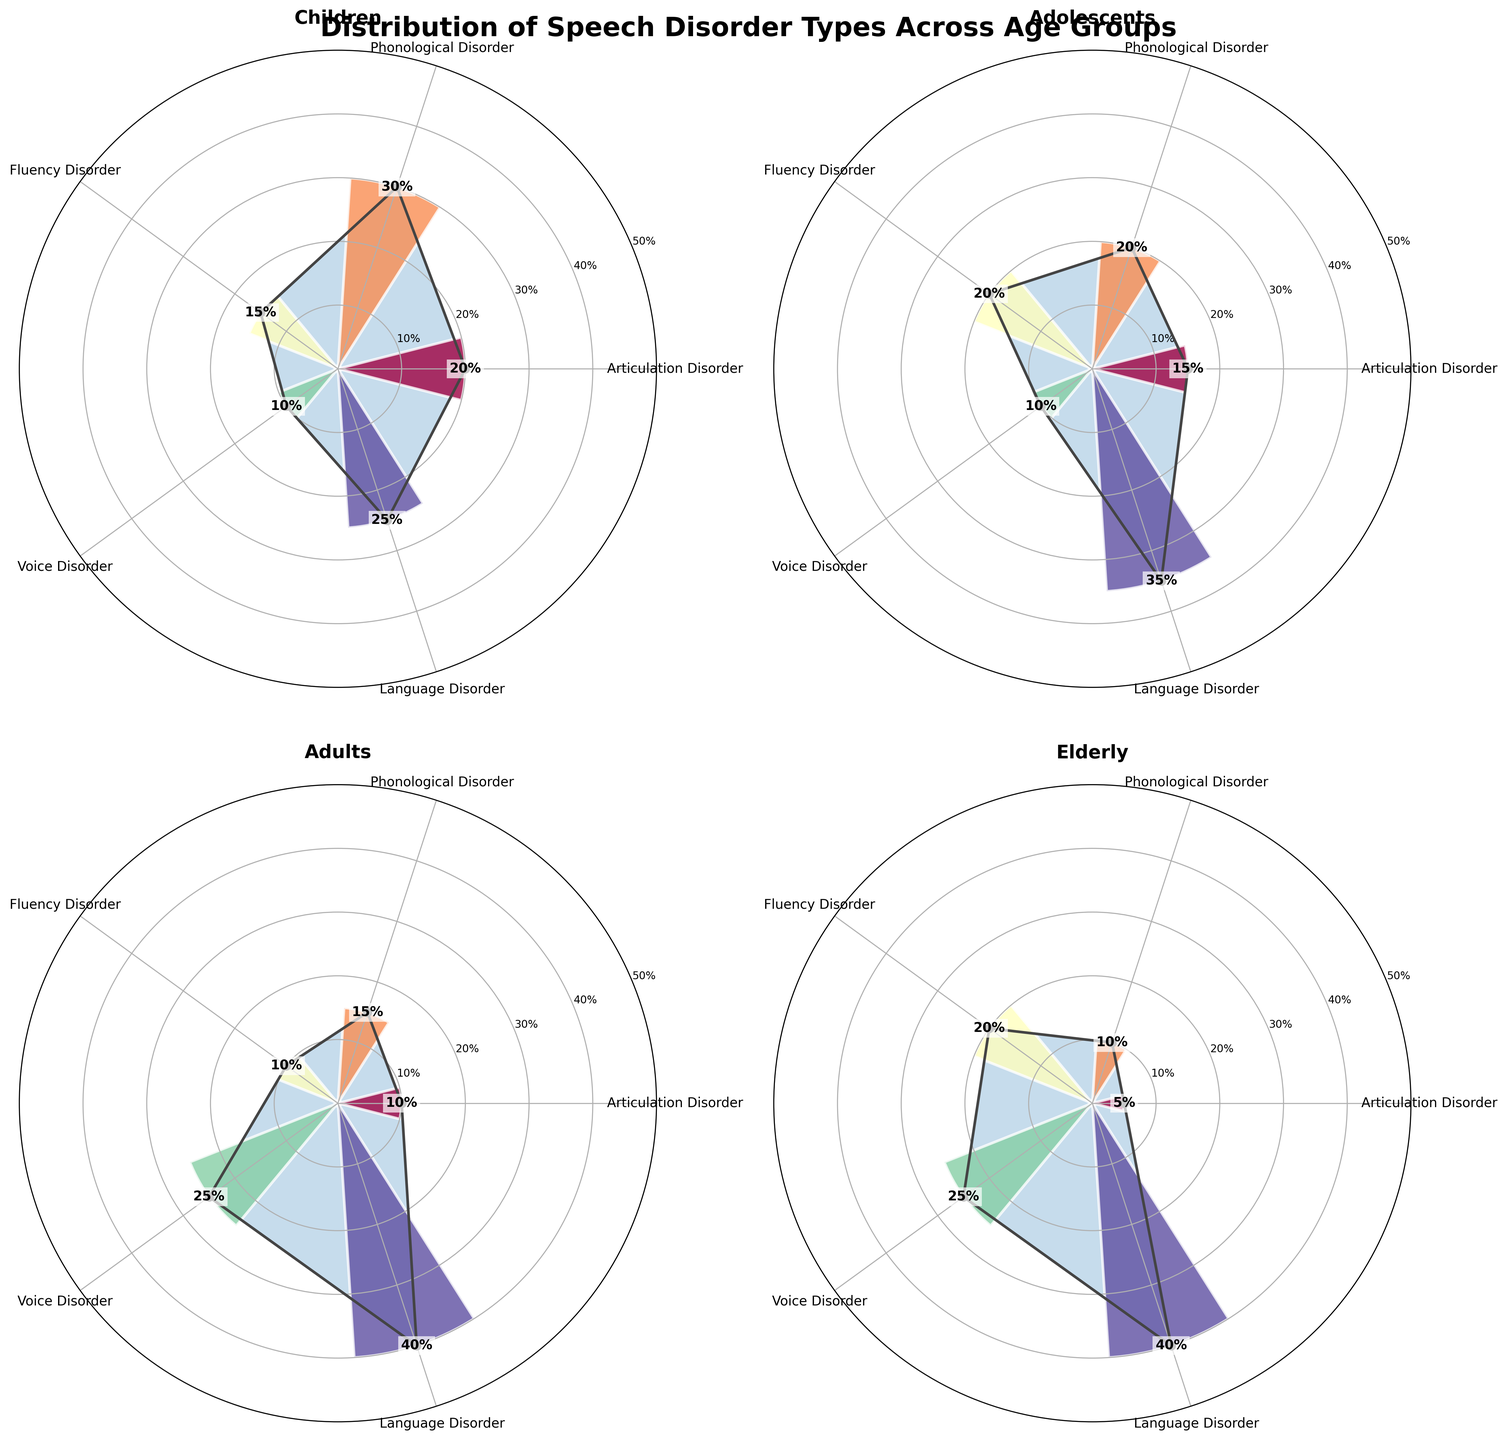What are the different types of speech disorders presented in the figure? The figure showcases five different speech disorder types as radial sections in each subplot. They are Articulation Disorder, Phonological Disorder, Fluency Disorder, Voice Disorder, and Language Disorder.
Answer: Articulation Disorder, Phonological Disorder, Fluency Disorder, Voice Disorder, Language Disorder Which age group has the highest percentage of Language Disorders? By visually inspecting the percentage values of Language Disorders in each subplot, you find the highest value within the "Elderly" group at 40%.
Answer: Elderly In the "Children" age group, which speech disorder has the lowest prevalence? Examining the "Children" subplot, the disorder with the smallest percentage is "Voice Disorder" with 10%.
Answer: Voice Disorder Compare the prevalence of Fluency Disorders between "Adolescents" and "Adults". Which age group has a higher percentage? The Fluency Disorder percentage for "Adolescents" is 20%, whereas for "Adults" it is 10%. Thus, "Adolescents" have a higher percentage.
Answer: Adolescents What is the combined percentage of Articulation Disorders across all age groups? Summing the percentages of Articulation Disorders from each age group: 20% (Children) + 15% (Adolescents) + 10% (Adults) + 5% (Elderly) equals 50%.
Answer: 50% Which speech disorder has an equal percentage across two different age groups, and what are those groups? Reviewing the subplots, "Voice Disorder" has a 25% prevalence in both "Adults" and "Elderly".
Answer: Voice Disorder, Adults, Elderly In the "Elderly" age group, what is the angle on the rose chart corresponding to Phonological Disorders? Each subplot represents 360 degrees divided equally among 5 disorders. Thus, each section is 72 degrees. Phonological Disorder is the second section, so its angle is 72 degrees from the start (0 degrees).
Answer: 72 degrees What is the percentage difference in the prevalence of Language Disorders between "Children" and "Adolescents"? The percentage for "Children" is 25% and for "Adolescents" is 35%. The difference is 35% - 25% = 10%.
Answer: 10% Which speech disorder in the "Adults" age group has the second-highest prevalence? Inspecting the percentages for "Adults," the highest is Language Disorder (40%), and the second-highest is Voice Disorder (25%).
Answer: Voice Disorder Is there any speech disorder type that presents an increasing trend in prevalence from "Children" to "Elderly"? Observing each disorder type's percentage across age groups, "Language Disorder" increases from 25% (Children) to 40% (Elderly).
Answer: Language Disorder 